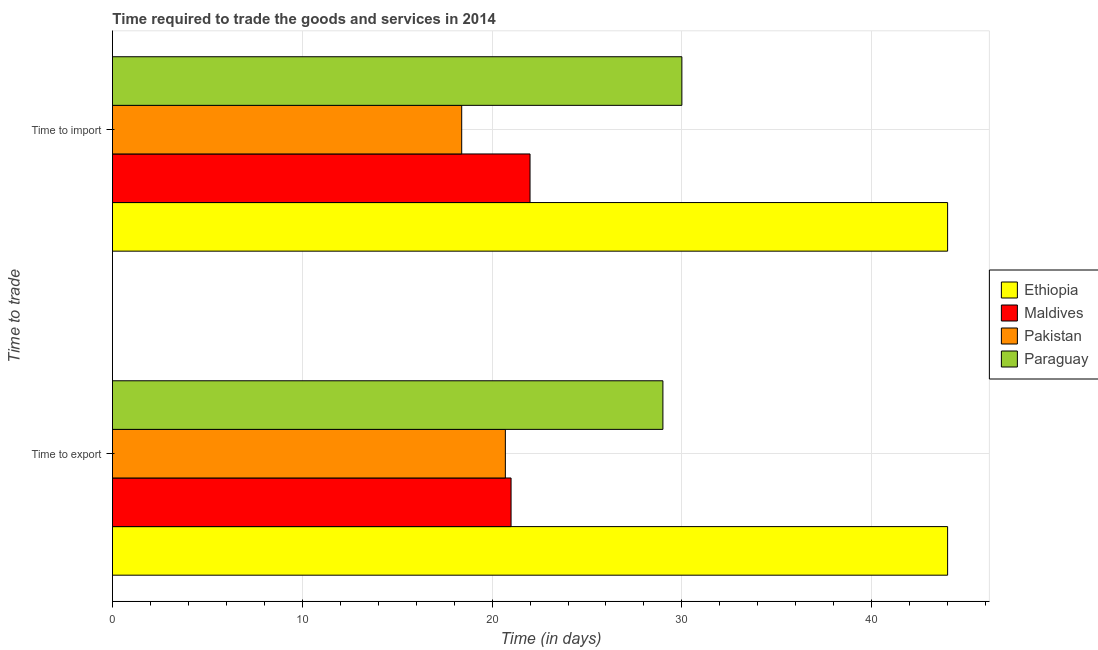How many bars are there on the 1st tick from the top?
Ensure brevity in your answer.  4. How many bars are there on the 2nd tick from the bottom?
Offer a very short reply. 4. What is the label of the 1st group of bars from the top?
Your answer should be very brief. Time to import. Across all countries, what is the maximum time to export?
Your answer should be compact. 44. Across all countries, what is the minimum time to export?
Make the answer very short. 20.7. In which country was the time to export maximum?
Keep it short and to the point. Ethiopia. In which country was the time to export minimum?
Provide a succinct answer. Pakistan. What is the total time to import in the graph?
Provide a succinct answer. 114.4. What is the difference between the time to export in Pakistan and the time to import in Maldives?
Offer a terse response. -1.3. What is the average time to import per country?
Ensure brevity in your answer.  28.6. In how many countries, is the time to export greater than 8 days?
Provide a short and direct response. 4. What is the ratio of the time to import in Paraguay to that in Maldives?
Ensure brevity in your answer.  1.36. In how many countries, is the time to export greater than the average time to export taken over all countries?
Make the answer very short. 2. What does the 1st bar from the top in Time to import represents?
Keep it short and to the point. Paraguay. What does the 3rd bar from the bottom in Time to export represents?
Your answer should be very brief. Pakistan. How many bars are there?
Ensure brevity in your answer.  8. Are all the bars in the graph horizontal?
Give a very brief answer. Yes. How many countries are there in the graph?
Keep it short and to the point. 4. What is the difference between two consecutive major ticks on the X-axis?
Keep it short and to the point. 10. Are the values on the major ticks of X-axis written in scientific E-notation?
Keep it short and to the point. No. Does the graph contain grids?
Offer a terse response. Yes. How many legend labels are there?
Offer a very short reply. 4. How are the legend labels stacked?
Provide a succinct answer. Vertical. What is the title of the graph?
Provide a succinct answer. Time required to trade the goods and services in 2014. What is the label or title of the X-axis?
Your answer should be very brief. Time (in days). What is the label or title of the Y-axis?
Provide a succinct answer. Time to trade. What is the Time (in days) of Ethiopia in Time to export?
Your answer should be compact. 44. What is the Time (in days) of Pakistan in Time to export?
Ensure brevity in your answer.  20.7. What is the Time (in days) in Pakistan in Time to import?
Offer a terse response. 18.4. What is the Time (in days) in Paraguay in Time to import?
Provide a short and direct response. 30. Across all Time to trade, what is the maximum Time (in days) in Maldives?
Ensure brevity in your answer.  22. Across all Time to trade, what is the maximum Time (in days) in Pakistan?
Your answer should be compact. 20.7. Across all Time to trade, what is the minimum Time (in days) in Maldives?
Your response must be concise. 21. Across all Time to trade, what is the minimum Time (in days) of Pakistan?
Offer a terse response. 18.4. What is the total Time (in days) of Pakistan in the graph?
Provide a short and direct response. 39.1. What is the difference between the Time (in days) in Ethiopia in Time to export and that in Time to import?
Give a very brief answer. 0. What is the difference between the Time (in days) in Maldives in Time to export and that in Time to import?
Provide a succinct answer. -1. What is the difference between the Time (in days) in Ethiopia in Time to export and the Time (in days) in Pakistan in Time to import?
Your answer should be compact. 25.6. What is the difference between the Time (in days) of Ethiopia in Time to export and the Time (in days) of Paraguay in Time to import?
Offer a terse response. 14. What is the difference between the Time (in days) of Maldives in Time to export and the Time (in days) of Pakistan in Time to import?
Provide a succinct answer. 2.6. What is the difference between the Time (in days) in Maldives in Time to export and the Time (in days) in Paraguay in Time to import?
Provide a succinct answer. -9. What is the difference between the Time (in days) of Pakistan in Time to export and the Time (in days) of Paraguay in Time to import?
Offer a terse response. -9.3. What is the average Time (in days) in Ethiopia per Time to trade?
Offer a terse response. 44. What is the average Time (in days) in Pakistan per Time to trade?
Provide a succinct answer. 19.55. What is the average Time (in days) in Paraguay per Time to trade?
Your answer should be very brief. 29.5. What is the difference between the Time (in days) of Ethiopia and Time (in days) of Maldives in Time to export?
Give a very brief answer. 23. What is the difference between the Time (in days) in Ethiopia and Time (in days) in Pakistan in Time to export?
Provide a short and direct response. 23.3. What is the difference between the Time (in days) of Ethiopia and Time (in days) of Paraguay in Time to export?
Your answer should be compact. 15. What is the difference between the Time (in days) in Maldives and Time (in days) in Pakistan in Time to export?
Provide a succinct answer. 0.3. What is the difference between the Time (in days) in Maldives and Time (in days) in Paraguay in Time to export?
Provide a succinct answer. -8. What is the difference between the Time (in days) of Pakistan and Time (in days) of Paraguay in Time to export?
Your answer should be very brief. -8.3. What is the difference between the Time (in days) of Ethiopia and Time (in days) of Pakistan in Time to import?
Provide a succinct answer. 25.6. What is the difference between the Time (in days) in Maldives and Time (in days) in Pakistan in Time to import?
Provide a short and direct response. 3.6. What is the difference between the Time (in days) in Maldives and Time (in days) in Paraguay in Time to import?
Your response must be concise. -8. What is the difference between the Time (in days) in Pakistan and Time (in days) in Paraguay in Time to import?
Your response must be concise. -11.6. What is the ratio of the Time (in days) of Maldives in Time to export to that in Time to import?
Make the answer very short. 0.95. What is the ratio of the Time (in days) in Paraguay in Time to export to that in Time to import?
Your answer should be very brief. 0.97. What is the difference between the highest and the second highest Time (in days) of Ethiopia?
Ensure brevity in your answer.  0. What is the difference between the highest and the second highest Time (in days) in Maldives?
Provide a short and direct response. 1. What is the difference between the highest and the second highest Time (in days) of Paraguay?
Offer a very short reply. 1. What is the difference between the highest and the lowest Time (in days) of Ethiopia?
Make the answer very short. 0. What is the difference between the highest and the lowest Time (in days) of Maldives?
Ensure brevity in your answer.  1. 